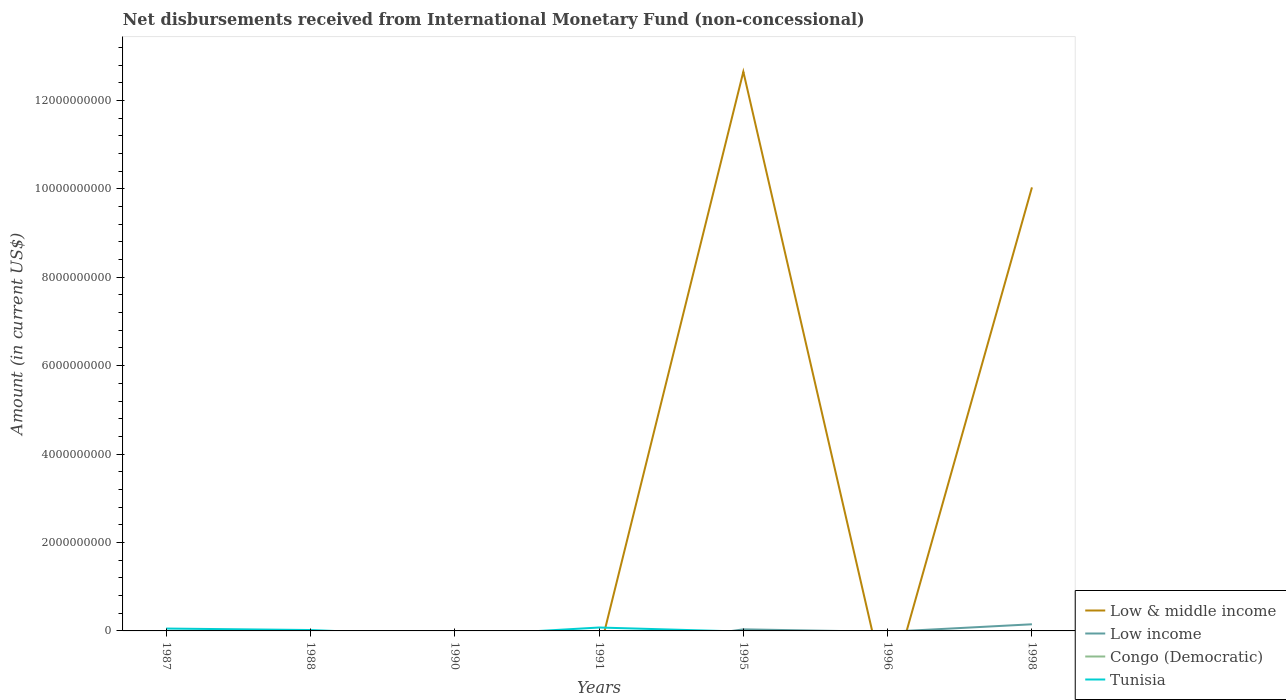How many different coloured lines are there?
Your answer should be very brief. 3. Across all years, what is the maximum amount of disbursements received from International Monetary Fund in Tunisia?
Provide a short and direct response. 0. What is the difference between the highest and the second highest amount of disbursements received from International Monetary Fund in Low & middle income?
Offer a very short reply. 1.26e+1. Is the amount of disbursements received from International Monetary Fund in Congo (Democratic) strictly greater than the amount of disbursements received from International Monetary Fund in Low & middle income over the years?
Your answer should be compact. No. How many lines are there?
Offer a very short reply. 3. Are the values on the major ticks of Y-axis written in scientific E-notation?
Keep it short and to the point. No. Does the graph contain any zero values?
Your response must be concise. Yes. How are the legend labels stacked?
Your answer should be very brief. Vertical. What is the title of the graph?
Give a very brief answer. Net disbursements received from International Monetary Fund (non-concessional). What is the label or title of the Y-axis?
Give a very brief answer. Amount (in current US$). What is the Amount (in current US$) of Low & middle income in 1987?
Your answer should be very brief. 0. What is the Amount (in current US$) of Tunisia in 1987?
Offer a very short reply. 5.37e+07. What is the Amount (in current US$) in Low & middle income in 1988?
Make the answer very short. 0. What is the Amount (in current US$) of Low income in 1988?
Make the answer very short. 0. What is the Amount (in current US$) of Congo (Democratic) in 1988?
Provide a short and direct response. 0. What is the Amount (in current US$) in Tunisia in 1988?
Your answer should be compact. 2.02e+07. What is the Amount (in current US$) in Low & middle income in 1990?
Your answer should be very brief. 0. What is the Amount (in current US$) of Low income in 1990?
Your answer should be compact. 0. What is the Amount (in current US$) of Congo (Democratic) in 1990?
Keep it short and to the point. 0. What is the Amount (in current US$) in Tunisia in 1990?
Ensure brevity in your answer.  0. What is the Amount (in current US$) in Congo (Democratic) in 1991?
Provide a succinct answer. 0. What is the Amount (in current US$) in Tunisia in 1991?
Give a very brief answer. 7.71e+07. What is the Amount (in current US$) in Low & middle income in 1995?
Your answer should be very brief. 1.26e+1. What is the Amount (in current US$) in Low income in 1995?
Your answer should be very brief. 3.56e+07. What is the Amount (in current US$) of Congo (Democratic) in 1995?
Ensure brevity in your answer.  0. What is the Amount (in current US$) of Tunisia in 1995?
Provide a short and direct response. 0. What is the Amount (in current US$) in Low income in 1996?
Provide a short and direct response. 0. What is the Amount (in current US$) of Congo (Democratic) in 1996?
Make the answer very short. 0. What is the Amount (in current US$) in Low & middle income in 1998?
Give a very brief answer. 1.00e+1. What is the Amount (in current US$) of Low income in 1998?
Offer a terse response. 1.50e+08. What is the Amount (in current US$) in Congo (Democratic) in 1998?
Ensure brevity in your answer.  0. Across all years, what is the maximum Amount (in current US$) of Low & middle income?
Your answer should be very brief. 1.26e+1. Across all years, what is the maximum Amount (in current US$) in Low income?
Provide a short and direct response. 1.50e+08. Across all years, what is the maximum Amount (in current US$) in Tunisia?
Make the answer very short. 7.71e+07. Across all years, what is the minimum Amount (in current US$) in Low & middle income?
Give a very brief answer. 0. Across all years, what is the minimum Amount (in current US$) of Low income?
Make the answer very short. 0. Across all years, what is the minimum Amount (in current US$) of Tunisia?
Your answer should be compact. 0. What is the total Amount (in current US$) in Low & middle income in the graph?
Ensure brevity in your answer.  2.27e+1. What is the total Amount (in current US$) in Low income in the graph?
Keep it short and to the point. 1.86e+08. What is the total Amount (in current US$) in Congo (Democratic) in the graph?
Ensure brevity in your answer.  0. What is the total Amount (in current US$) in Tunisia in the graph?
Your answer should be very brief. 1.51e+08. What is the difference between the Amount (in current US$) of Tunisia in 1987 and that in 1988?
Give a very brief answer. 3.35e+07. What is the difference between the Amount (in current US$) in Tunisia in 1987 and that in 1991?
Keep it short and to the point. -2.34e+07. What is the difference between the Amount (in current US$) in Tunisia in 1988 and that in 1991?
Give a very brief answer. -5.70e+07. What is the difference between the Amount (in current US$) of Low & middle income in 1995 and that in 1998?
Keep it short and to the point. 2.62e+09. What is the difference between the Amount (in current US$) in Low income in 1995 and that in 1998?
Ensure brevity in your answer.  -1.15e+08. What is the difference between the Amount (in current US$) of Low & middle income in 1995 and the Amount (in current US$) of Low income in 1998?
Provide a succinct answer. 1.25e+1. What is the average Amount (in current US$) of Low & middle income per year?
Offer a very short reply. 3.24e+09. What is the average Amount (in current US$) of Low income per year?
Provide a short and direct response. 2.66e+07. What is the average Amount (in current US$) of Tunisia per year?
Make the answer very short. 2.16e+07. In the year 1995, what is the difference between the Amount (in current US$) in Low & middle income and Amount (in current US$) in Low income?
Give a very brief answer. 1.26e+1. In the year 1998, what is the difference between the Amount (in current US$) in Low & middle income and Amount (in current US$) in Low income?
Provide a succinct answer. 9.88e+09. What is the ratio of the Amount (in current US$) in Tunisia in 1987 to that in 1988?
Your answer should be very brief. 2.66. What is the ratio of the Amount (in current US$) of Tunisia in 1987 to that in 1991?
Ensure brevity in your answer.  0.7. What is the ratio of the Amount (in current US$) in Tunisia in 1988 to that in 1991?
Offer a terse response. 0.26. What is the ratio of the Amount (in current US$) in Low & middle income in 1995 to that in 1998?
Your answer should be compact. 1.26. What is the ratio of the Amount (in current US$) of Low income in 1995 to that in 1998?
Give a very brief answer. 0.24. What is the difference between the highest and the second highest Amount (in current US$) of Tunisia?
Give a very brief answer. 2.34e+07. What is the difference between the highest and the lowest Amount (in current US$) of Low & middle income?
Offer a terse response. 1.26e+1. What is the difference between the highest and the lowest Amount (in current US$) of Low income?
Make the answer very short. 1.50e+08. What is the difference between the highest and the lowest Amount (in current US$) of Tunisia?
Your answer should be compact. 7.71e+07. 